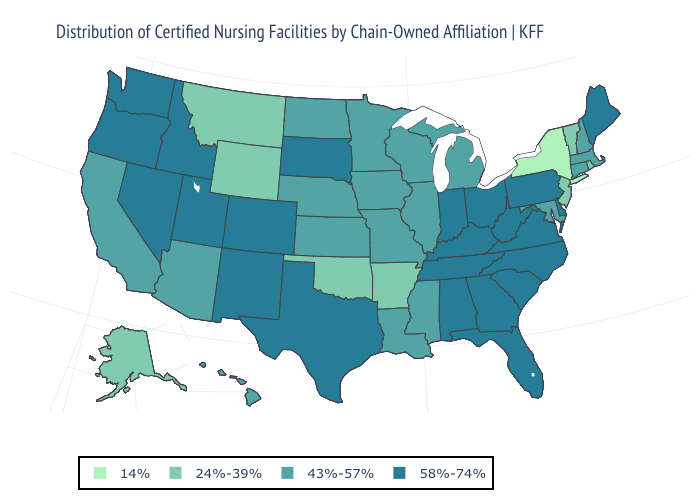How many symbols are there in the legend?
Be succinct. 4. What is the value of North Dakota?
Answer briefly. 43%-57%. What is the lowest value in the Northeast?
Concise answer only. 14%. Name the states that have a value in the range 58%-74%?
Write a very short answer. Alabama, Colorado, Delaware, Florida, Georgia, Idaho, Indiana, Kentucky, Maine, Nevada, New Mexico, North Carolina, Ohio, Oregon, Pennsylvania, South Carolina, South Dakota, Tennessee, Texas, Utah, Virginia, Washington, West Virginia. Which states have the lowest value in the South?
Short answer required. Arkansas, Oklahoma. Which states hav the highest value in the Northeast?
Quick response, please. Maine, Pennsylvania. Name the states that have a value in the range 43%-57%?
Give a very brief answer. Arizona, California, Connecticut, Hawaii, Illinois, Iowa, Kansas, Louisiana, Maryland, Massachusetts, Michigan, Minnesota, Mississippi, Missouri, Nebraska, New Hampshire, North Dakota, Wisconsin. Does the map have missing data?
Write a very short answer. No. What is the value of West Virginia?
Short answer required. 58%-74%. Name the states that have a value in the range 24%-39%?
Give a very brief answer. Alaska, Arkansas, Montana, New Jersey, Oklahoma, Rhode Island, Vermont, Wyoming. What is the value of Wyoming?
Be succinct. 24%-39%. What is the value of Nevada?
Keep it brief. 58%-74%. Name the states that have a value in the range 24%-39%?
Be succinct. Alaska, Arkansas, Montana, New Jersey, Oklahoma, Rhode Island, Vermont, Wyoming. Does the first symbol in the legend represent the smallest category?
Concise answer only. Yes. 